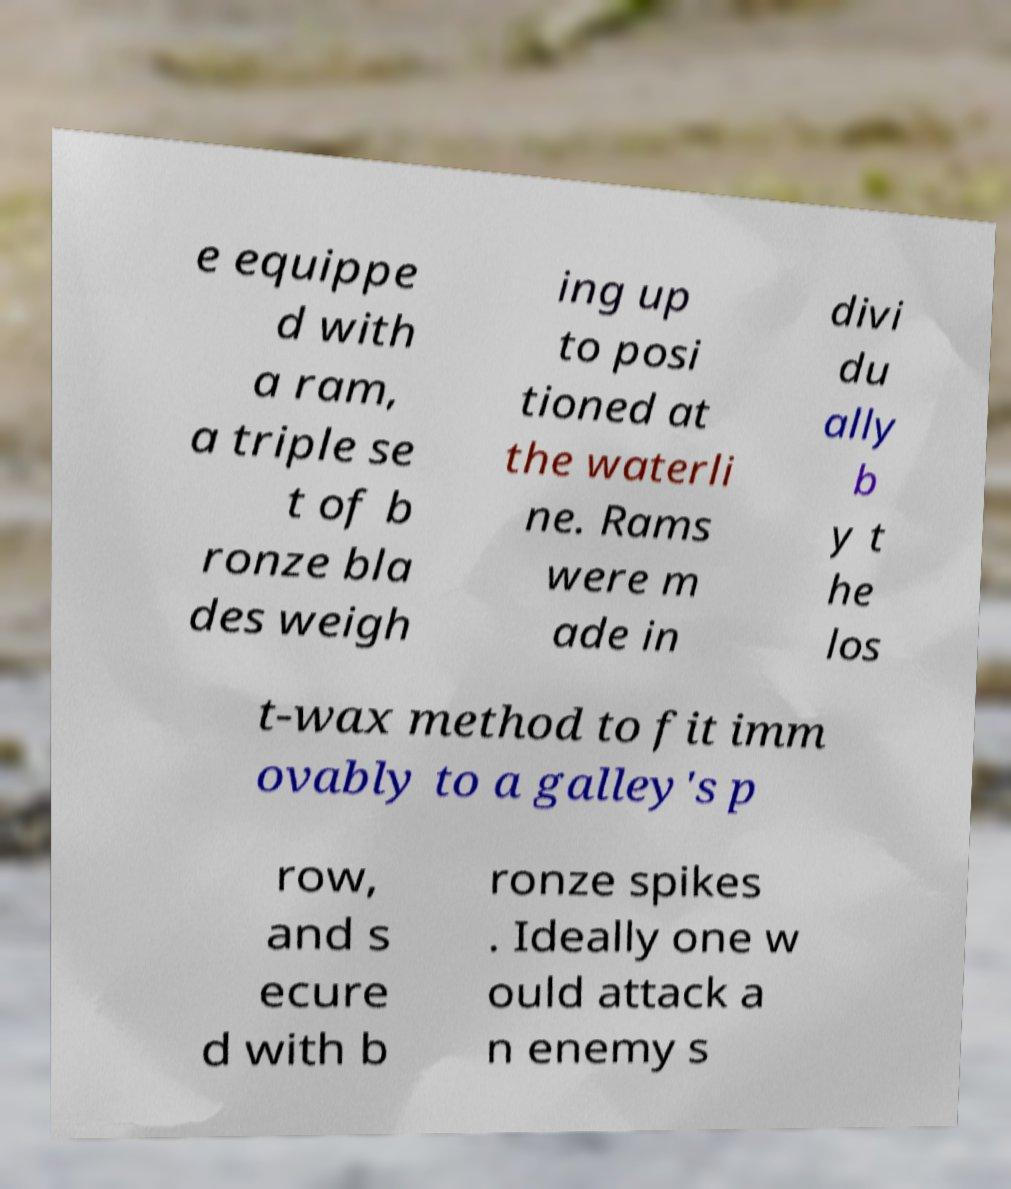What messages or text are displayed in this image? I need them in a readable, typed format. e equippe d with a ram, a triple se t of b ronze bla des weigh ing up to posi tioned at the waterli ne. Rams were m ade in divi du ally b y t he los t-wax method to fit imm ovably to a galley's p row, and s ecure d with b ronze spikes . Ideally one w ould attack a n enemy s 